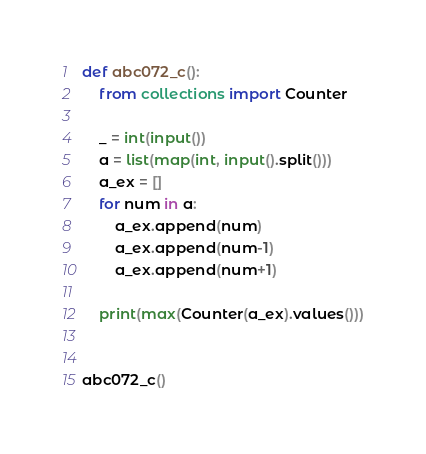<code> <loc_0><loc_0><loc_500><loc_500><_Python_>def abc072_c():
    from collections import Counter
 
    _ = int(input())
    a = list(map(int, input().split()))
    a_ex = []
    for num in a:
        a_ex.append(num)
        a_ex.append(num-1)
        a_ex.append(num+1)
 
    print(max(Counter(a_ex).values()))
 
 
abc072_c()</code> 